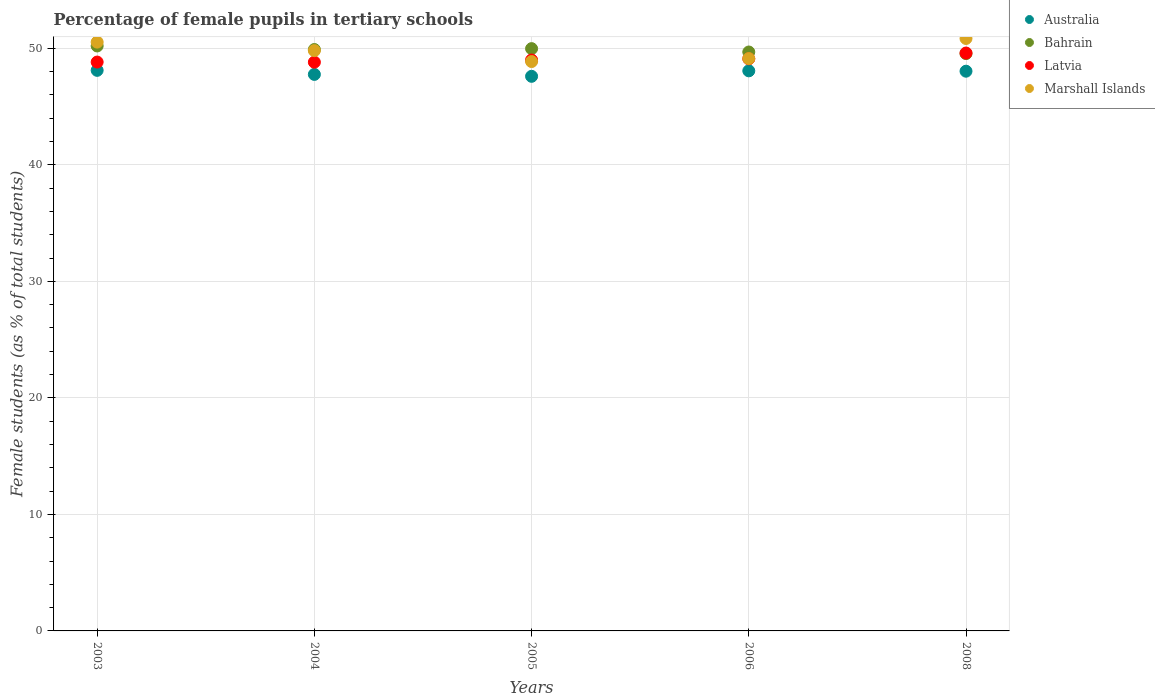Is the number of dotlines equal to the number of legend labels?
Keep it short and to the point. Yes. What is the percentage of female pupils in tertiary schools in Latvia in 2004?
Your answer should be very brief. 48.8. Across all years, what is the maximum percentage of female pupils in tertiary schools in Bahrain?
Your answer should be very brief. 50.2. Across all years, what is the minimum percentage of female pupils in tertiary schools in Bahrain?
Ensure brevity in your answer.  49.54. In which year was the percentage of female pupils in tertiary schools in Marshall Islands maximum?
Offer a very short reply. 2008. What is the total percentage of female pupils in tertiary schools in Bahrain in the graph?
Keep it short and to the point. 249.27. What is the difference between the percentage of female pupils in tertiary schools in Marshall Islands in 2005 and that in 2008?
Your response must be concise. -1.98. What is the difference between the percentage of female pupils in tertiary schools in Latvia in 2003 and the percentage of female pupils in tertiary schools in Australia in 2008?
Your response must be concise. 0.78. What is the average percentage of female pupils in tertiary schools in Bahrain per year?
Give a very brief answer. 49.85. In the year 2003, what is the difference between the percentage of female pupils in tertiary schools in Bahrain and percentage of female pupils in tertiary schools in Australia?
Keep it short and to the point. 2.09. What is the ratio of the percentage of female pupils in tertiary schools in Australia in 2005 to that in 2006?
Give a very brief answer. 0.99. Is the percentage of female pupils in tertiary schools in Marshall Islands in 2004 less than that in 2008?
Your response must be concise. Yes. What is the difference between the highest and the second highest percentage of female pupils in tertiary schools in Australia?
Give a very brief answer. 0.04. What is the difference between the highest and the lowest percentage of female pupils in tertiary schools in Bahrain?
Offer a terse response. 0.66. In how many years, is the percentage of female pupils in tertiary schools in Australia greater than the average percentage of female pupils in tertiary schools in Australia taken over all years?
Provide a short and direct response. 3. Is it the case that in every year, the sum of the percentage of female pupils in tertiary schools in Australia and percentage of female pupils in tertiary schools in Latvia  is greater than the percentage of female pupils in tertiary schools in Marshall Islands?
Provide a succinct answer. Yes. Does the percentage of female pupils in tertiary schools in Bahrain monotonically increase over the years?
Keep it short and to the point. No. Is the percentage of female pupils in tertiary schools in Marshall Islands strictly greater than the percentage of female pupils in tertiary schools in Australia over the years?
Make the answer very short. Yes. How many years are there in the graph?
Ensure brevity in your answer.  5. Does the graph contain any zero values?
Provide a short and direct response. No. Does the graph contain grids?
Your response must be concise. Yes. How many legend labels are there?
Offer a very short reply. 4. What is the title of the graph?
Ensure brevity in your answer.  Percentage of female pupils in tertiary schools. What is the label or title of the X-axis?
Provide a succinct answer. Years. What is the label or title of the Y-axis?
Give a very brief answer. Female students (as % of total students). What is the Female students (as % of total students) of Australia in 2003?
Provide a short and direct response. 48.1. What is the Female students (as % of total students) of Bahrain in 2003?
Ensure brevity in your answer.  50.2. What is the Female students (as % of total students) in Latvia in 2003?
Ensure brevity in your answer.  48.82. What is the Female students (as % of total students) in Marshall Islands in 2003?
Your response must be concise. 50.53. What is the Female students (as % of total students) in Australia in 2004?
Your answer should be compact. 47.76. What is the Female students (as % of total students) in Bahrain in 2004?
Offer a very short reply. 49.89. What is the Female students (as % of total students) of Latvia in 2004?
Provide a succinct answer. 48.8. What is the Female students (as % of total students) of Marshall Islands in 2004?
Your answer should be very brief. 49.79. What is the Female students (as % of total students) of Australia in 2005?
Give a very brief answer. 47.59. What is the Female students (as % of total students) in Bahrain in 2005?
Make the answer very short. 49.97. What is the Female students (as % of total students) in Latvia in 2005?
Your answer should be very brief. 48.99. What is the Female students (as % of total students) of Marshall Islands in 2005?
Your answer should be compact. 48.86. What is the Female students (as % of total students) in Australia in 2006?
Your answer should be compact. 48.06. What is the Female students (as % of total students) of Bahrain in 2006?
Keep it short and to the point. 49.68. What is the Female students (as % of total students) of Latvia in 2006?
Provide a short and direct response. 49.09. What is the Female students (as % of total students) in Marshall Islands in 2006?
Your answer should be very brief. 49.12. What is the Female students (as % of total students) of Australia in 2008?
Keep it short and to the point. 48.03. What is the Female students (as % of total students) of Bahrain in 2008?
Ensure brevity in your answer.  49.54. What is the Female students (as % of total students) in Latvia in 2008?
Offer a terse response. 49.59. What is the Female students (as % of total students) of Marshall Islands in 2008?
Offer a very short reply. 50.84. Across all years, what is the maximum Female students (as % of total students) in Australia?
Offer a terse response. 48.1. Across all years, what is the maximum Female students (as % of total students) in Bahrain?
Offer a terse response. 50.2. Across all years, what is the maximum Female students (as % of total students) in Latvia?
Give a very brief answer. 49.59. Across all years, what is the maximum Female students (as % of total students) in Marshall Islands?
Provide a succinct answer. 50.84. Across all years, what is the minimum Female students (as % of total students) in Australia?
Provide a succinct answer. 47.59. Across all years, what is the minimum Female students (as % of total students) in Bahrain?
Offer a terse response. 49.54. Across all years, what is the minimum Female students (as % of total students) in Latvia?
Offer a very short reply. 48.8. Across all years, what is the minimum Female students (as % of total students) in Marshall Islands?
Your response must be concise. 48.86. What is the total Female students (as % of total students) in Australia in the graph?
Your response must be concise. 239.54. What is the total Female students (as % of total students) in Bahrain in the graph?
Offer a very short reply. 249.27. What is the total Female students (as % of total students) of Latvia in the graph?
Provide a succinct answer. 245.3. What is the total Female students (as % of total students) of Marshall Islands in the graph?
Offer a very short reply. 249.14. What is the difference between the Female students (as % of total students) of Australia in 2003 and that in 2004?
Keep it short and to the point. 0.35. What is the difference between the Female students (as % of total students) in Bahrain in 2003 and that in 2004?
Give a very brief answer. 0.31. What is the difference between the Female students (as % of total students) in Latvia in 2003 and that in 2004?
Make the answer very short. 0.01. What is the difference between the Female students (as % of total students) in Marshall Islands in 2003 and that in 2004?
Offer a very short reply. 0.73. What is the difference between the Female students (as % of total students) in Australia in 2003 and that in 2005?
Make the answer very short. 0.51. What is the difference between the Female students (as % of total students) in Bahrain in 2003 and that in 2005?
Keep it short and to the point. 0.23. What is the difference between the Female students (as % of total students) of Latvia in 2003 and that in 2005?
Your answer should be very brief. -0.18. What is the difference between the Female students (as % of total students) in Marshall Islands in 2003 and that in 2005?
Give a very brief answer. 1.67. What is the difference between the Female students (as % of total students) in Australia in 2003 and that in 2006?
Offer a very short reply. 0.04. What is the difference between the Female students (as % of total students) of Bahrain in 2003 and that in 2006?
Your response must be concise. 0.52. What is the difference between the Female students (as % of total students) of Latvia in 2003 and that in 2006?
Provide a succinct answer. -0.28. What is the difference between the Female students (as % of total students) of Marshall Islands in 2003 and that in 2006?
Your response must be concise. 1.41. What is the difference between the Female students (as % of total students) in Australia in 2003 and that in 2008?
Keep it short and to the point. 0.07. What is the difference between the Female students (as % of total students) of Bahrain in 2003 and that in 2008?
Give a very brief answer. 0.66. What is the difference between the Female students (as % of total students) in Latvia in 2003 and that in 2008?
Offer a terse response. -0.77. What is the difference between the Female students (as % of total students) of Marshall Islands in 2003 and that in 2008?
Give a very brief answer. -0.31. What is the difference between the Female students (as % of total students) of Australia in 2004 and that in 2005?
Keep it short and to the point. 0.16. What is the difference between the Female students (as % of total students) in Bahrain in 2004 and that in 2005?
Offer a terse response. -0.08. What is the difference between the Female students (as % of total students) of Latvia in 2004 and that in 2005?
Keep it short and to the point. -0.19. What is the difference between the Female students (as % of total students) in Marshall Islands in 2004 and that in 2005?
Offer a terse response. 0.94. What is the difference between the Female students (as % of total students) of Australia in 2004 and that in 2006?
Keep it short and to the point. -0.31. What is the difference between the Female students (as % of total students) in Bahrain in 2004 and that in 2006?
Your answer should be compact. 0.21. What is the difference between the Female students (as % of total students) of Latvia in 2004 and that in 2006?
Give a very brief answer. -0.29. What is the difference between the Female students (as % of total students) of Marshall Islands in 2004 and that in 2006?
Make the answer very short. 0.68. What is the difference between the Female students (as % of total students) in Australia in 2004 and that in 2008?
Offer a very short reply. -0.28. What is the difference between the Female students (as % of total students) of Bahrain in 2004 and that in 2008?
Offer a terse response. 0.35. What is the difference between the Female students (as % of total students) in Latvia in 2004 and that in 2008?
Offer a very short reply. -0.78. What is the difference between the Female students (as % of total students) in Marshall Islands in 2004 and that in 2008?
Offer a terse response. -1.05. What is the difference between the Female students (as % of total students) in Australia in 2005 and that in 2006?
Your response must be concise. -0.47. What is the difference between the Female students (as % of total students) of Bahrain in 2005 and that in 2006?
Give a very brief answer. 0.29. What is the difference between the Female students (as % of total students) of Latvia in 2005 and that in 2006?
Provide a succinct answer. -0.1. What is the difference between the Female students (as % of total students) in Marshall Islands in 2005 and that in 2006?
Provide a succinct answer. -0.26. What is the difference between the Female students (as % of total students) of Australia in 2005 and that in 2008?
Give a very brief answer. -0.44. What is the difference between the Female students (as % of total students) in Bahrain in 2005 and that in 2008?
Your response must be concise. 0.43. What is the difference between the Female students (as % of total students) of Latvia in 2005 and that in 2008?
Your response must be concise. -0.6. What is the difference between the Female students (as % of total students) of Marshall Islands in 2005 and that in 2008?
Your answer should be very brief. -1.98. What is the difference between the Female students (as % of total students) in Australia in 2006 and that in 2008?
Your answer should be very brief. 0.03. What is the difference between the Female students (as % of total students) of Bahrain in 2006 and that in 2008?
Your answer should be very brief. 0.14. What is the difference between the Female students (as % of total students) of Latvia in 2006 and that in 2008?
Keep it short and to the point. -0.5. What is the difference between the Female students (as % of total students) of Marshall Islands in 2006 and that in 2008?
Provide a succinct answer. -1.72. What is the difference between the Female students (as % of total students) in Australia in 2003 and the Female students (as % of total students) in Bahrain in 2004?
Give a very brief answer. -1.79. What is the difference between the Female students (as % of total students) of Australia in 2003 and the Female students (as % of total students) of Latvia in 2004?
Ensure brevity in your answer.  -0.7. What is the difference between the Female students (as % of total students) of Australia in 2003 and the Female students (as % of total students) of Marshall Islands in 2004?
Offer a very short reply. -1.69. What is the difference between the Female students (as % of total students) in Bahrain in 2003 and the Female students (as % of total students) in Latvia in 2004?
Offer a very short reply. 1.39. What is the difference between the Female students (as % of total students) in Bahrain in 2003 and the Female students (as % of total students) in Marshall Islands in 2004?
Keep it short and to the point. 0.4. What is the difference between the Female students (as % of total students) in Latvia in 2003 and the Female students (as % of total students) in Marshall Islands in 2004?
Offer a terse response. -0.98. What is the difference between the Female students (as % of total students) of Australia in 2003 and the Female students (as % of total students) of Bahrain in 2005?
Offer a terse response. -1.86. What is the difference between the Female students (as % of total students) in Australia in 2003 and the Female students (as % of total students) in Latvia in 2005?
Provide a succinct answer. -0.89. What is the difference between the Female students (as % of total students) of Australia in 2003 and the Female students (as % of total students) of Marshall Islands in 2005?
Provide a short and direct response. -0.76. What is the difference between the Female students (as % of total students) in Bahrain in 2003 and the Female students (as % of total students) in Latvia in 2005?
Ensure brevity in your answer.  1.2. What is the difference between the Female students (as % of total students) of Bahrain in 2003 and the Female students (as % of total students) of Marshall Islands in 2005?
Provide a succinct answer. 1.34. What is the difference between the Female students (as % of total students) of Latvia in 2003 and the Female students (as % of total students) of Marshall Islands in 2005?
Offer a very short reply. -0.04. What is the difference between the Female students (as % of total students) of Australia in 2003 and the Female students (as % of total students) of Bahrain in 2006?
Provide a succinct answer. -1.57. What is the difference between the Female students (as % of total students) in Australia in 2003 and the Female students (as % of total students) in Latvia in 2006?
Provide a short and direct response. -0.99. What is the difference between the Female students (as % of total students) in Australia in 2003 and the Female students (as % of total students) in Marshall Islands in 2006?
Offer a very short reply. -1.01. What is the difference between the Female students (as % of total students) of Bahrain in 2003 and the Female students (as % of total students) of Latvia in 2006?
Your answer should be very brief. 1.1. What is the difference between the Female students (as % of total students) of Bahrain in 2003 and the Female students (as % of total students) of Marshall Islands in 2006?
Offer a very short reply. 1.08. What is the difference between the Female students (as % of total students) in Latvia in 2003 and the Female students (as % of total students) in Marshall Islands in 2006?
Provide a succinct answer. -0.3. What is the difference between the Female students (as % of total students) of Australia in 2003 and the Female students (as % of total students) of Bahrain in 2008?
Your answer should be very brief. -1.44. What is the difference between the Female students (as % of total students) of Australia in 2003 and the Female students (as % of total students) of Latvia in 2008?
Provide a succinct answer. -1.49. What is the difference between the Female students (as % of total students) in Australia in 2003 and the Female students (as % of total students) in Marshall Islands in 2008?
Make the answer very short. -2.74. What is the difference between the Female students (as % of total students) in Bahrain in 2003 and the Female students (as % of total students) in Latvia in 2008?
Your answer should be compact. 0.61. What is the difference between the Female students (as % of total students) in Bahrain in 2003 and the Female students (as % of total students) in Marshall Islands in 2008?
Offer a very short reply. -0.64. What is the difference between the Female students (as % of total students) in Latvia in 2003 and the Female students (as % of total students) in Marshall Islands in 2008?
Provide a succinct answer. -2.02. What is the difference between the Female students (as % of total students) in Australia in 2004 and the Female students (as % of total students) in Bahrain in 2005?
Keep it short and to the point. -2.21. What is the difference between the Female students (as % of total students) in Australia in 2004 and the Female students (as % of total students) in Latvia in 2005?
Make the answer very short. -1.24. What is the difference between the Female students (as % of total students) in Australia in 2004 and the Female students (as % of total students) in Marshall Islands in 2005?
Offer a terse response. -1.1. What is the difference between the Female students (as % of total students) of Bahrain in 2004 and the Female students (as % of total students) of Latvia in 2005?
Offer a very short reply. 0.9. What is the difference between the Female students (as % of total students) of Bahrain in 2004 and the Female students (as % of total students) of Marshall Islands in 2005?
Provide a succinct answer. 1.03. What is the difference between the Female students (as % of total students) in Latvia in 2004 and the Female students (as % of total students) in Marshall Islands in 2005?
Provide a short and direct response. -0.05. What is the difference between the Female students (as % of total students) in Australia in 2004 and the Female students (as % of total students) in Bahrain in 2006?
Keep it short and to the point. -1.92. What is the difference between the Female students (as % of total students) in Australia in 2004 and the Female students (as % of total students) in Latvia in 2006?
Provide a succinct answer. -1.34. What is the difference between the Female students (as % of total students) of Australia in 2004 and the Female students (as % of total students) of Marshall Islands in 2006?
Provide a succinct answer. -1.36. What is the difference between the Female students (as % of total students) of Bahrain in 2004 and the Female students (as % of total students) of Latvia in 2006?
Provide a succinct answer. 0.8. What is the difference between the Female students (as % of total students) of Bahrain in 2004 and the Female students (as % of total students) of Marshall Islands in 2006?
Offer a very short reply. 0.78. What is the difference between the Female students (as % of total students) of Latvia in 2004 and the Female students (as % of total students) of Marshall Islands in 2006?
Provide a succinct answer. -0.31. What is the difference between the Female students (as % of total students) of Australia in 2004 and the Female students (as % of total students) of Bahrain in 2008?
Make the answer very short. -1.78. What is the difference between the Female students (as % of total students) in Australia in 2004 and the Female students (as % of total students) in Latvia in 2008?
Your response must be concise. -1.83. What is the difference between the Female students (as % of total students) in Australia in 2004 and the Female students (as % of total students) in Marshall Islands in 2008?
Your answer should be very brief. -3.08. What is the difference between the Female students (as % of total students) of Bahrain in 2004 and the Female students (as % of total students) of Latvia in 2008?
Make the answer very short. 0.3. What is the difference between the Female students (as % of total students) of Bahrain in 2004 and the Female students (as % of total students) of Marshall Islands in 2008?
Offer a very short reply. -0.95. What is the difference between the Female students (as % of total students) of Latvia in 2004 and the Female students (as % of total students) of Marshall Islands in 2008?
Your response must be concise. -2.04. What is the difference between the Female students (as % of total students) of Australia in 2005 and the Female students (as % of total students) of Bahrain in 2006?
Provide a succinct answer. -2.09. What is the difference between the Female students (as % of total students) of Australia in 2005 and the Female students (as % of total students) of Latvia in 2006?
Your response must be concise. -1.5. What is the difference between the Female students (as % of total students) of Australia in 2005 and the Female students (as % of total students) of Marshall Islands in 2006?
Provide a succinct answer. -1.52. What is the difference between the Female students (as % of total students) in Bahrain in 2005 and the Female students (as % of total students) in Latvia in 2006?
Provide a short and direct response. 0.88. What is the difference between the Female students (as % of total students) in Bahrain in 2005 and the Female students (as % of total students) in Marshall Islands in 2006?
Make the answer very short. 0.85. What is the difference between the Female students (as % of total students) of Latvia in 2005 and the Female students (as % of total students) of Marshall Islands in 2006?
Your answer should be very brief. -0.12. What is the difference between the Female students (as % of total students) of Australia in 2005 and the Female students (as % of total students) of Bahrain in 2008?
Provide a short and direct response. -1.95. What is the difference between the Female students (as % of total students) in Australia in 2005 and the Female students (as % of total students) in Latvia in 2008?
Your answer should be very brief. -2. What is the difference between the Female students (as % of total students) of Australia in 2005 and the Female students (as % of total students) of Marshall Islands in 2008?
Ensure brevity in your answer.  -3.25. What is the difference between the Female students (as % of total students) in Bahrain in 2005 and the Female students (as % of total students) in Latvia in 2008?
Give a very brief answer. 0.38. What is the difference between the Female students (as % of total students) in Bahrain in 2005 and the Female students (as % of total students) in Marshall Islands in 2008?
Offer a very short reply. -0.87. What is the difference between the Female students (as % of total students) in Latvia in 2005 and the Female students (as % of total students) in Marshall Islands in 2008?
Keep it short and to the point. -1.85. What is the difference between the Female students (as % of total students) in Australia in 2006 and the Female students (as % of total students) in Bahrain in 2008?
Provide a succinct answer. -1.48. What is the difference between the Female students (as % of total students) in Australia in 2006 and the Female students (as % of total students) in Latvia in 2008?
Your answer should be very brief. -1.53. What is the difference between the Female students (as % of total students) in Australia in 2006 and the Female students (as % of total students) in Marshall Islands in 2008?
Provide a short and direct response. -2.78. What is the difference between the Female students (as % of total students) in Bahrain in 2006 and the Female students (as % of total students) in Latvia in 2008?
Offer a terse response. 0.09. What is the difference between the Female students (as % of total students) in Bahrain in 2006 and the Female students (as % of total students) in Marshall Islands in 2008?
Ensure brevity in your answer.  -1.16. What is the difference between the Female students (as % of total students) of Latvia in 2006 and the Female students (as % of total students) of Marshall Islands in 2008?
Your answer should be very brief. -1.75. What is the average Female students (as % of total students) of Australia per year?
Make the answer very short. 47.91. What is the average Female students (as % of total students) in Bahrain per year?
Your response must be concise. 49.85. What is the average Female students (as % of total students) in Latvia per year?
Offer a very short reply. 49.06. What is the average Female students (as % of total students) of Marshall Islands per year?
Your answer should be compact. 49.83. In the year 2003, what is the difference between the Female students (as % of total students) in Australia and Female students (as % of total students) in Bahrain?
Your answer should be very brief. -2.09. In the year 2003, what is the difference between the Female students (as % of total students) in Australia and Female students (as % of total students) in Latvia?
Provide a short and direct response. -0.71. In the year 2003, what is the difference between the Female students (as % of total students) of Australia and Female students (as % of total students) of Marshall Islands?
Ensure brevity in your answer.  -2.42. In the year 2003, what is the difference between the Female students (as % of total students) of Bahrain and Female students (as % of total students) of Latvia?
Ensure brevity in your answer.  1.38. In the year 2003, what is the difference between the Female students (as % of total students) of Bahrain and Female students (as % of total students) of Marshall Islands?
Keep it short and to the point. -0.33. In the year 2003, what is the difference between the Female students (as % of total students) in Latvia and Female students (as % of total students) in Marshall Islands?
Keep it short and to the point. -1.71. In the year 2004, what is the difference between the Female students (as % of total students) of Australia and Female students (as % of total students) of Bahrain?
Ensure brevity in your answer.  -2.13. In the year 2004, what is the difference between the Female students (as % of total students) in Australia and Female students (as % of total students) in Latvia?
Your answer should be compact. -1.05. In the year 2004, what is the difference between the Female students (as % of total students) of Australia and Female students (as % of total students) of Marshall Islands?
Give a very brief answer. -2.04. In the year 2004, what is the difference between the Female students (as % of total students) in Bahrain and Female students (as % of total students) in Latvia?
Ensure brevity in your answer.  1.09. In the year 2004, what is the difference between the Female students (as % of total students) in Bahrain and Female students (as % of total students) in Marshall Islands?
Offer a terse response. 0.1. In the year 2004, what is the difference between the Female students (as % of total students) of Latvia and Female students (as % of total students) of Marshall Islands?
Keep it short and to the point. -0.99. In the year 2005, what is the difference between the Female students (as % of total students) in Australia and Female students (as % of total students) in Bahrain?
Offer a very short reply. -2.38. In the year 2005, what is the difference between the Female students (as % of total students) of Australia and Female students (as % of total students) of Latvia?
Ensure brevity in your answer.  -1.4. In the year 2005, what is the difference between the Female students (as % of total students) of Australia and Female students (as % of total students) of Marshall Islands?
Provide a short and direct response. -1.27. In the year 2005, what is the difference between the Female students (as % of total students) in Bahrain and Female students (as % of total students) in Latvia?
Make the answer very short. 0.97. In the year 2005, what is the difference between the Female students (as % of total students) of Bahrain and Female students (as % of total students) of Marshall Islands?
Provide a succinct answer. 1.11. In the year 2005, what is the difference between the Female students (as % of total students) of Latvia and Female students (as % of total students) of Marshall Islands?
Offer a terse response. 0.13. In the year 2006, what is the difference between the Female students (as % of total students) of Australia and Female students (as % of total students) of Bahrain?
Provide a short and direct response. -1.62. In the year 2006, what is the difference between the Female students (as % of total students) in Australia and Female students (as % of total students) in Latvia?
Provide a succinct answer. -1.03. In the year 2006, what is the difference between the Female students (as % of total students) of Australia and Female students (as % of total students) of Marshall Islands?
Give a very brief answer. -1.05. In the year 2006, what is the difference between the Female students (as % of total students) in Bahrain and Female students (as % of total students) in Latvia?
Offer a very short reply. 0.59. In the year 2006, what is the difference between the Female students (as % of total students) of Bahrain and Female students (as % of total students) of Marshall Islands?
Keep it short and to the point. 0.56. In the year 2006, what is the difference between the Female students (as % of total students) of Latvia and Female students (as % of total students) of Marshall Islands?
Your response must be concise. -0.02. In the year 2008, what is the difference between the Female students (as % of total students) of Australia and Female students (as % of total students) of Bahrain?
Provide a succinct answer. -1.51. In the year 2008, what is the difference between the Female students (as % of total students) of Australia and Female students (as % of total students) of Latvia?
Ensure brevity in your answer.  -1.56. In the year 2008, what is the difference between the Female students (as % of total students) in Australia and Female students (as % of total students) in Marshall Islands?
Give a very brief answer. -2.81. In the year 2008, what is the difference between the Female students (as % of total students) of Bahrain and Female students (as % of total students) of Latvia?
Offer a very short reply. -0.05. In the year 2008, what is the difference between the Female students (as % of total students) of Bahrain and Female students (as % of total students) of Marshall Islands?
Give a very brief answer. -1.3. In the year 2008, what is the difference between the Female students (as % of total students) of Latvia and Female students (as % of total students) of Marshall Islands?
Make the answer very short. -1.25. What is the ratio of the Female students (as % of total students) of Australia in 2003 to that in 2004?
Your response must be concise. 1.01. What is the ratio of the Female students (as % of total students) in Bahrain in 2003 to that in 2004?
Provide a succinct answer. 1.01. What is the ratio of the Female students (as % of total students) of Marshall Islands in 2003 to that in 2004?
Ensure brevity in your answer.  1.01. What is the ratio of the Female students (as % of total students) of Australia in 2003 to that in 2005?
Your answer should be compact. 1.01. What is the ratio of the Female students (as % of total students) of Latvia in 2003 to that in 2005?
Your answer should be very brief. 1. What is the ratio of the Female students (as % of total students) of Marshall Islands in 2003 to that in 2005?
Offer a terse response. 1.03. What is the ratio of the Female students (as % of total students) in Australia in 2003 to that in 2006?
Make the answer very short. 1. What is the ratio of the Female students (as % of total students) of Bahrain in 2003 to that in 2006?
Offer a terse response. 1.01. What is the ratio of the Female students (as % of total students) of Marshall Islands in 2003 to that in 2006?
Keep it short and to the point. 1.03. What is the ratio of the Female students (as % of total students) of Australia in 2003 to that in 2008?
Your response must be concise. 1. What is the ratio of the Female students (as % of total students) in Bahrain in 2003 to that in 2008?
Offer a terse response. 1.01. What is the ratio of the Female students (as % of total students) in Latvia in 2003 to that in 2008?
Ensure brevity in your answer.  0.98. What is the ratio of the Female students (as % of total students) of Australia in 2004 to that in 2005?
Provide a short and direct response. 1. What is the ratio of the Female students (as % of total students) of Bahrain in 2004 to that in 2005?
Your response must be concise. 1. What is the ratio of the Female students (as % of total students) in Marshall Islands in 2004 to that in 2005?
Offer a terse response. 1.02. What is the ratio of the Female students (as % of total students) of Australia in 2004 to that in 2006?
Provide a short and direct response. 0.99. What is the ratio of the Female students (as % of total students) of Bahrain in 2004 to that in 2006?
Make the answer very short. 1. What is the ratio of the Female students (as % of total students) in Latvia in 2004 to that in 2006?
Your response must be concise. 0.99. What is the ratio of the Female students (as % of total students) in Marshall Islands in 2004 to that in 2006?
Your response must be concise. 1.01. What is the ratio of the Female students (as % of total students) of Bahrain in 2004 to that in 2008?
Offer a very short reply. 1.01. What is the ratio of the Female students (as % of total students) in Latvia in 2004 to that in 2008?
Offer a very short reply. 0.98. What is the ratio of the Female students (as % of total students) in Marshall Islands in 2004 to that in 2008?
Ensure brevity in your answer.  0.98. What is the ratio of the Female students (as % of total students) of Australia in 2005 to that in 2006?
Your answer should be very brief. 0.99. What is the ratio of the Female students (as % of total students) in Australia in 2005 to that in 2008?
Ensure brevity in your answer.  0.99. What is the ratio of the Female students (as % of total students) in Bahrain in 2005 to that in 2008?
Offer a terse response. 1.01. What is the ratio of the Female students (as % of total students) in Marshall Islands in 2005 to that in 2008?
Your answer should be compact. 0.96. What is the ratio of the Female students (as % of total students) in Australia in 2006 to that in 2008?
Your answer should be compact. 1. What is the ratio of the Female students (as % of total students) of Bahrain in 2006 to that in 2008?
Keep it short and to the point. 1. What is the ratio of the Female students (as % of total students) in Latvia in 2006 to that in 2008?
Keep it short and to the point. 0.99. What is the ratio of the Female students (as % of total students) in Marshall Islands in 2006 to that in 2008?
Provide a short and direct response. 0.97. What is the difference between the highest and the second highest Female students (as % of total students) of Australia?
Offer a terse response. 0.04. What is the difference between the highest and the second highest Female students (as % of total students) of Bahrain?
Give a very brief answer. 0.23. What is the difference between the highest and the second highest Female students (as % of total students) in Latvia?
Keep it short and to the point. 0.5. What is the difference between the highest and the second highest Female students (as % of total students) in Marshall Islands?
Make the answer very short. 0.31. What is the difference between the highest and the lowest Female students (as % of total students) in Australia?
Give a very brief answer. 0.51. What is the difference between the highest and the lowest Female students (as % of total students) in Bahrain?
Your answer should be very brief. 0.66. What is the difference between the highest and the lowest Female students (as % of total students) of Latvia?
Your response must be concise. 0.78. What is the difference between the highest and the lowest Female students (as % of total students) in Marshall Islands?
Give a very brief answer. 1.98. 